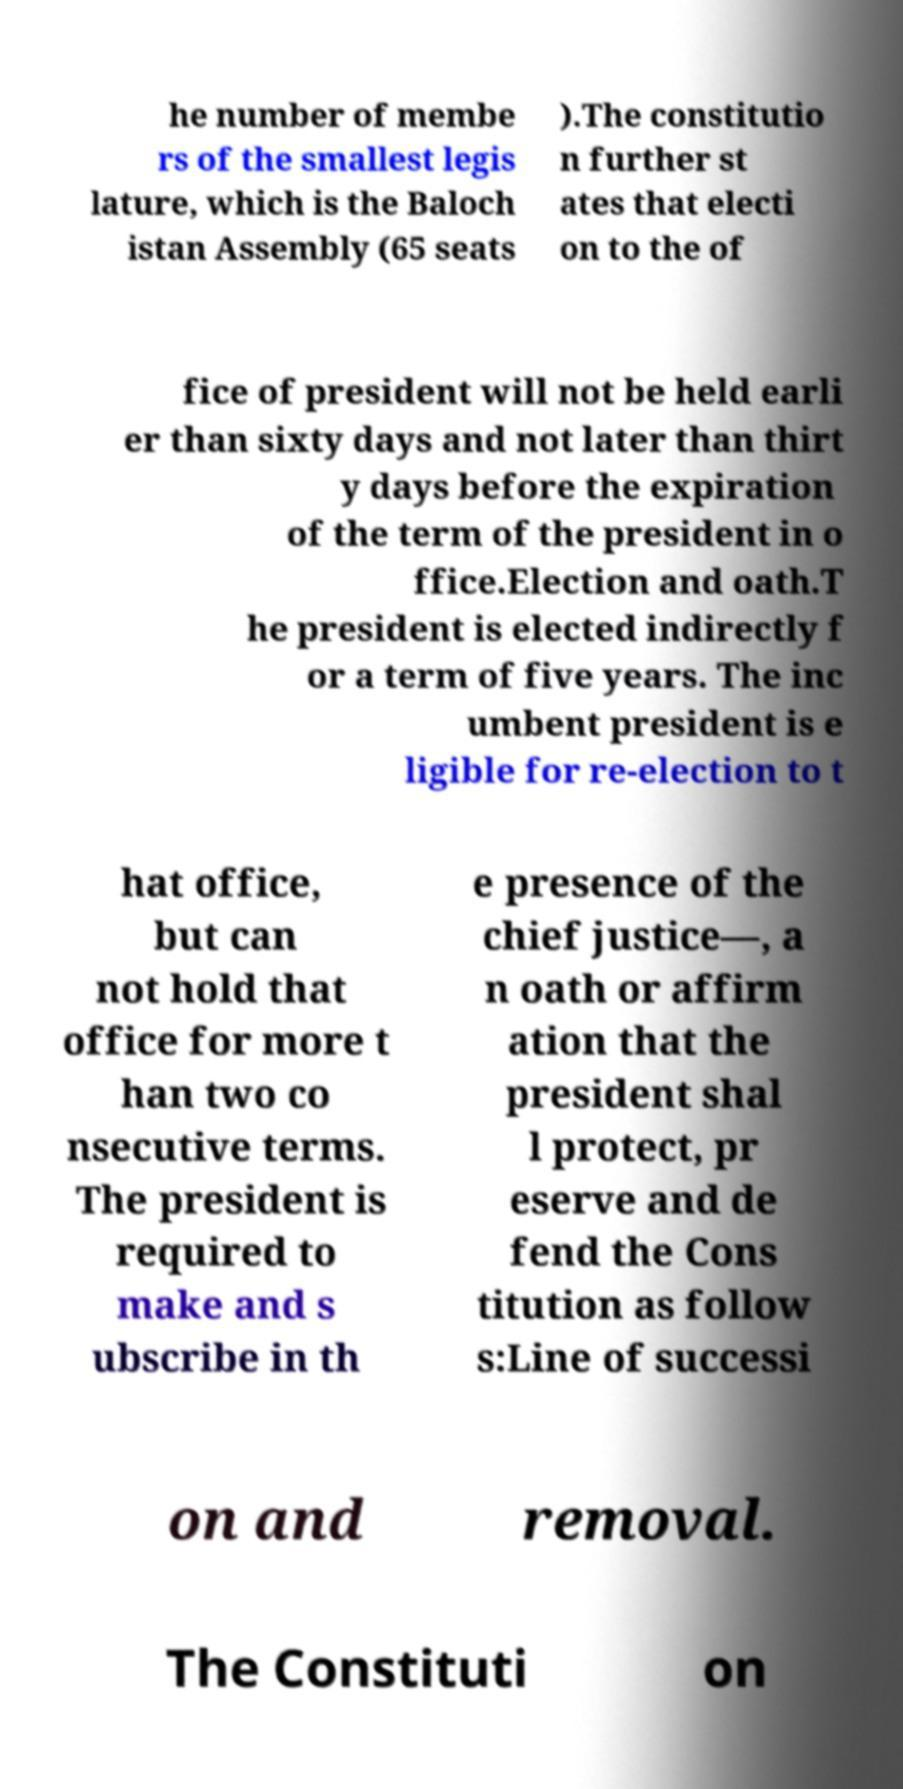Can you read and provide the text displayed in the image?This photo seems to have some interesting text. Can you extract and type it out for me? he number of membe rs of the smallest legis lature, which is the Baloch istan Assembly (65 seats ).The constitutio n further st ates that electi on to the of fice of president will not be held earli er than sixty days and not later than thirt y days before the expiration of the term of the president in o ffice.Election and oath.T he president is elected indirectly f or a term of five years. The inc umbent president is e ligible for re-election to t hat office, but can not hold that office for more t han two co nsecutive terms. The president is required to make and s ubscribe in th e presence of the chief justice—, a n oath or affirm ation that the president shal l protect, pr eserve and de fend the Cons titution as follow s:Line of successi on and removal. The Constituti on 